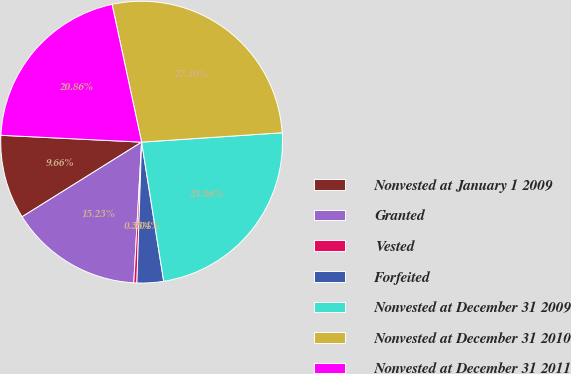Convert chart. <chart><loc_0><loc_0><loc_500><loc_500><pie_chart><fcel>Nonvested at January 1 2009<fcel>Granted<fcel>Vested<fcel>Forfeited<fcel>Nonvested at December 31 2009<fcel>Nonvested at December 31 2010<fcel>Nonvested at December 31 2011<nl><fcel>9.66%<fcel>15.23%<fcel>0.35%<fcel>3.04%<fcel>23.56%<fcel>27.3%<fcel>20.86%<nl></chart> 